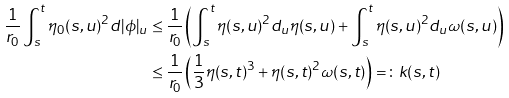<formula> <loc_0><loc_0><loc_500><loc_500>\frac { 1 } { r _ { 0 } } \int _ { s } ^ { t } \eta _ { 0 } ( s , u ) ^ { 2 } d | \phi | _ { u } & \leq \frac { 1 } { r _ { 0 } } \left ( \int _ { s } ^ { t } \eta ( s , u ) ^ { 2 } d _ { u } \eta ( s , u ) + \int _ { s } ^ { t } \eta ( s , u ) ^ { 2 } d _ { u } \omega ( s , u ) \right ) \\ & \leq \frac { 1 } { r _ { 0 } } \left ( \frac { 1 } { 3 } \eta ( s , t ) ^ { 3 } + \eta ( s , t ) ^ { 2 } \omega ( s , t ) \right ) = \colon k ( s , t )</formula> 